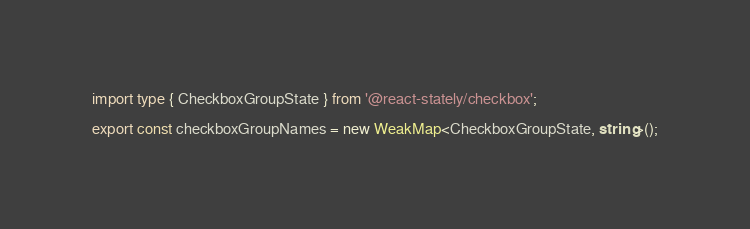Convert code to text. <code><loc_0><loc_0><loc_500><loc_500><_TypeScript_>import type { CheckboxGroupState } from '@react-stately/checkbox';

export const checkboxGroupNames = new WeakMap<CheckboxGroupState, string>();
</code> 